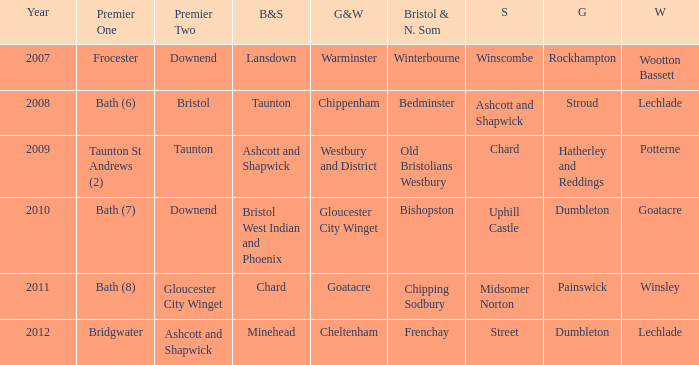Write the full table. {'header': ['Year', 'Premier One', 'Premier Two', 'B&S', 'G&W', 'Bristol & N. Som', 'S', 'G', 'W'], 'rows': [['2007', 'Frocester', 'Downend', 'Lansdown', 'Warminster', 'Winterbourne', 'Winscombe', 'Rockhampton', 'Wootton Bassett'], ['2008', 'Bath (6)', 'Bristol', 'Taunton', 'Chippenham', 'Bedminster', 'Ashcott and Shapwick', 'Stroud', 'Lechlade'], ['2009', 'Taunton St Andrews (2)', 'Taunton', 'Ashcott and Shapwick', 'Westbury and District', 'Old Bristolians Westbury', 'Chard', 'Hatherley and Reddings', 'Potterne'], ['2010', 'Bath (7)', 'Downend', 'Bristol West Indian and Phoenix', 'Gloucester City Winget', 'Bishopston', 'Uphill Castle', 'Dumbleton', 'Goatacre'], ['2011', 'Bath (8)', 'Gloucester City Winget', 'Chard', 'Goatacre', 'Chipping Sodbury', 'Midsomer Norton', 'Painswick', 'Winsley'], ['2012', 'Bridgwater', 'Ashcott and Shapwick', 'Minehead', 'Cheltenham', 'Frenchay', 'Street', 'Dumbleton', 'Lechlade']]} What is the bristol & n. som where the somerset is ashcott and shapwick? Bedminster. 